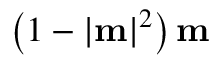<formula> <loc_0><loc_0><loc_500><loc_500>\left ( 1 - | m | ^ { 2 } \right ) m</formula> 